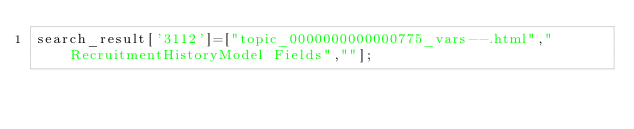<code> <loc_0><loc_0><loc_500><loc_500><_JavaScript_>search_result['3112']=["topic_0000000000000775_vars--.html","RecruitmentHistoryModel Fields",""];</code> 